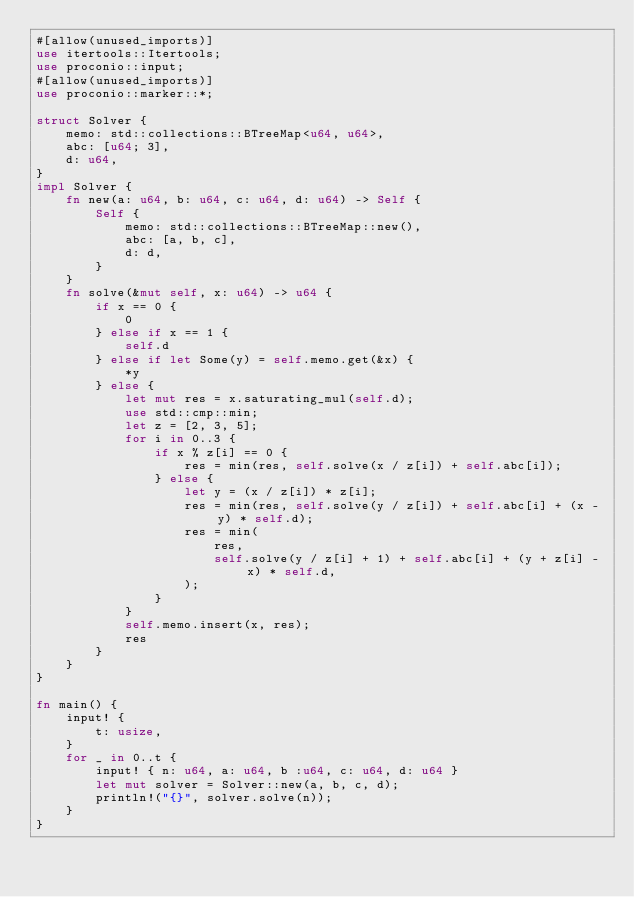Convert code to text. <code><loc_0><loc_0><loc_500><loc_500><_Rust_>#[allow(unused_imports)]
use itertools::Itertools;
use proconio::input;
#[allow(unused_imports)]
use proconio::marker::*;

struct Solver {
    memo: std::collections::BTreeMap<u64, u64>,
    abc: [u64; 3],
    d: u64,
}
impl Solver {
    fn new(a: u64, b: u64, c: u64, d: u64) -> Self {
        Self {
            memo: std::collections::BTreeMap::new(),
            abc: [a, b, c],
            d: d,
        }
    }
    fn solve(&mut self, x: u64) -> u64 {
        if x == 0 {
            0
        } else if x == 1 {
            self.d
        } else if let Some(y) = self.memo.get(&x) {
            *y
        } else {
            let mut res = x.saturating_mul(self.d);
            use std::cmp::min;
            let z = [2, 3, 5];
            for i in 0..3 {
                if x % z[i] == 0 {
                    res = min(res, self.solve(x / z[i]) + self.abc[i]);
                } else {
                    let y = (x / z[i]) * z[i];
                    res = min(res, self.solve(y / z[i]) + self.abc[i] + (x - y) * self.d);
                    res = min(
                        res,
                        self.solve(y / z[i] + 1) + self.abc[i] + (y + z[i] - x) * self.d,
                    );
                }
            }
            self.memo.insert(x, res);
            res
        }
    }
}

fn main() {
    input! {
        t: usize,
    }
    for _ in 0..t {
        input! { n: u64, a: u64, b :u64, c: u64, d: u64 }
        let mut solver = Solver::new(a, b, c, d);
        println!("{}", solver.solve(n));
    }
}
</code> 